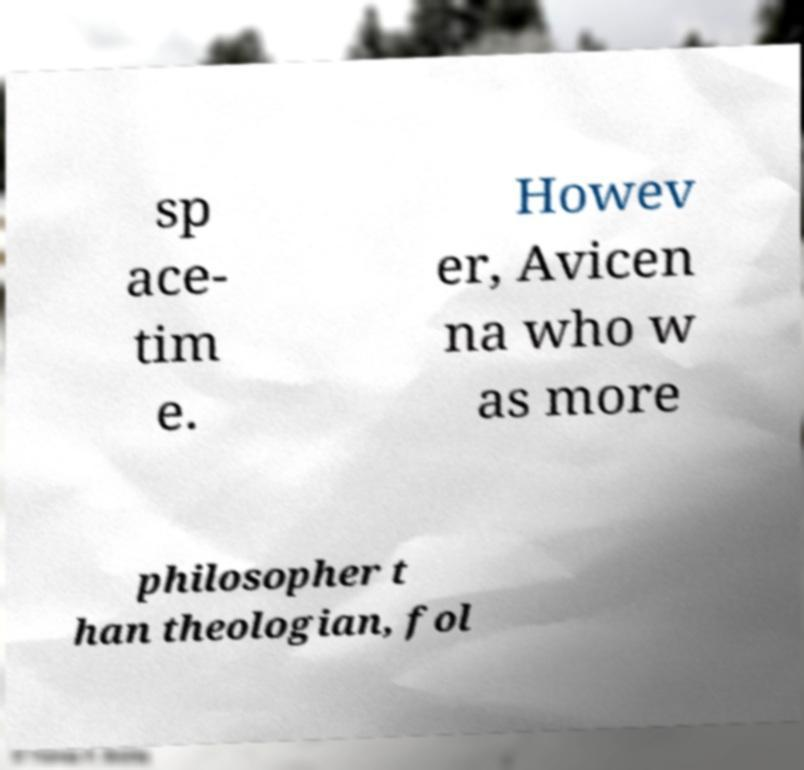Can you read and provide the text displayed in the image?This photo seems to have some interesting text. Can you extract and type it out for me? sp ace- tim e. Howev er, Avicen na who w as more philosopher t han theologian, fol 